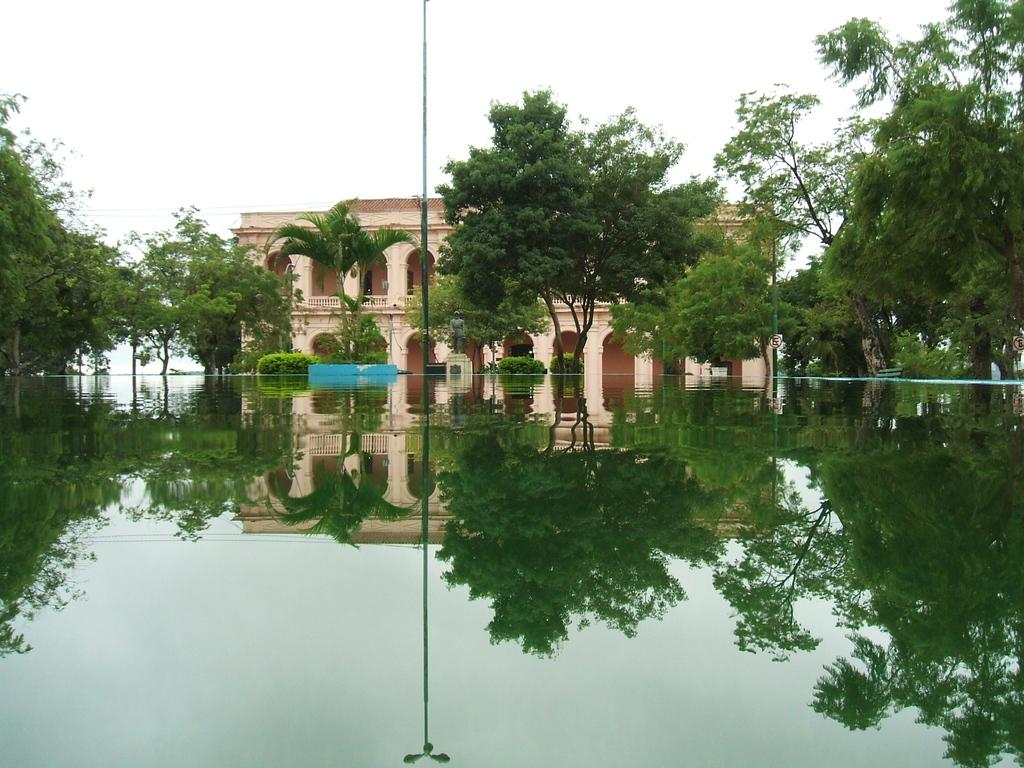What is present at the front of the image? There is water in the front of the image. What can be seen in the background of the image? There are trees, poles, and a building in the background of the image. What is the condition of the water in the image? There is a reflection on the water in the image. What type of cough can be heard in the image? There is no sound, including coughing, present in the image. What flavor of soda is visible in the image? There is no soda present in the image. 